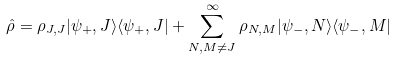Convert formula to latex. <formula><loc_0><loc_0><loc_500><loc_500>\hat { \rho } = \rho _ { J , J } | \psi _ { + } , J \rangle \langle \psi _ { + } , J | + \sum _ { N , M \neq J } ^ { \infty } \rho _ { N , M } | \psi _ { - } , N \rangle \langle \psi _ { - } , M |</formula> 